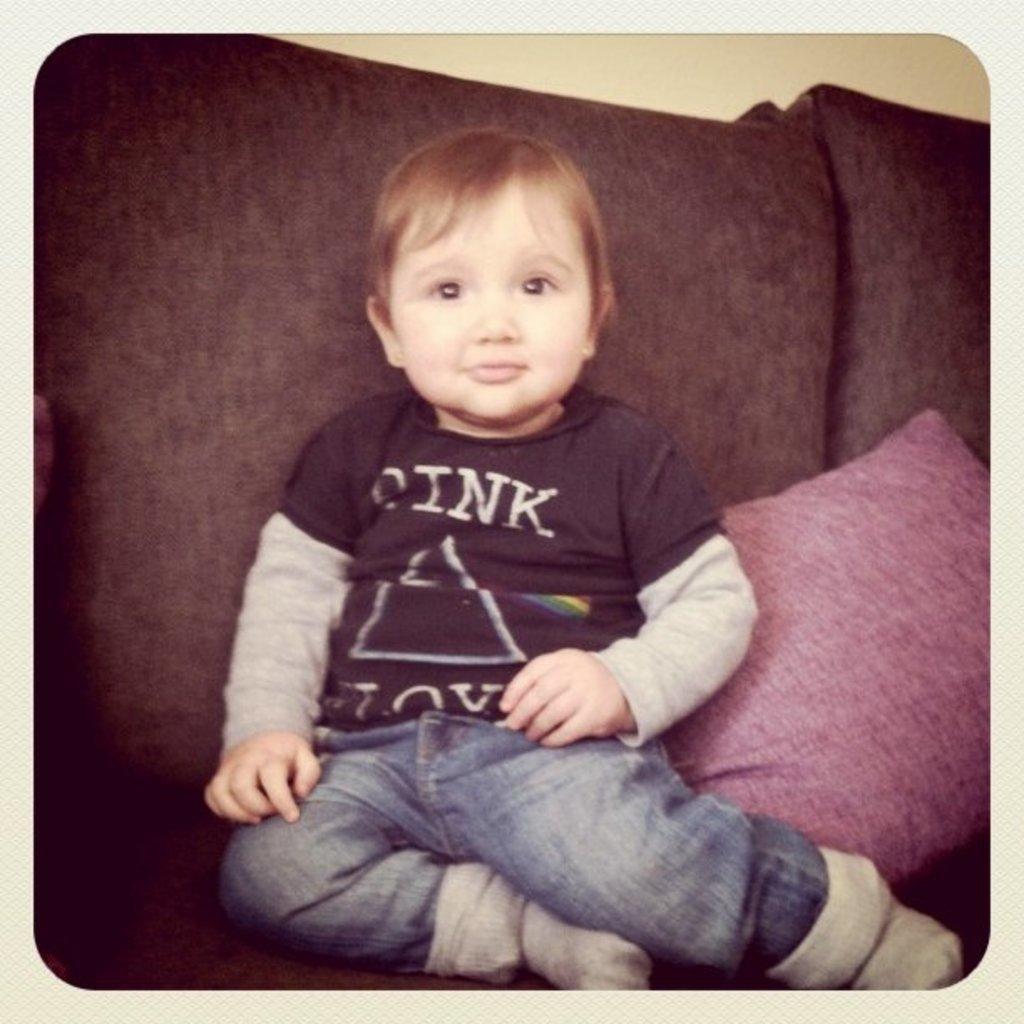How would you summarize this image in a sentence or two? As we can see in the image there is a boy sitting on red color sofa. 